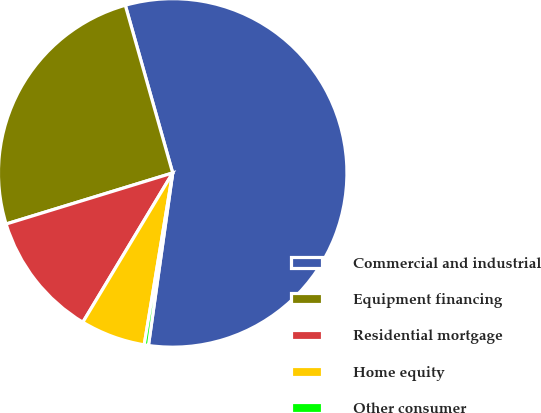Convert chart. <chart><loc_0><loc_0><loc_500><loc_500><pie_chart><fcel>Commercial and industrial<fcel>Equipment financing<fcel>Residential mortgage<fcel>Home equity<fcel>Other consumer<nl><fcel>56.6%<fcel>25.35%<fcel>11.64%<fcel>6.01%<fcel>0.39%<nl></chart> 